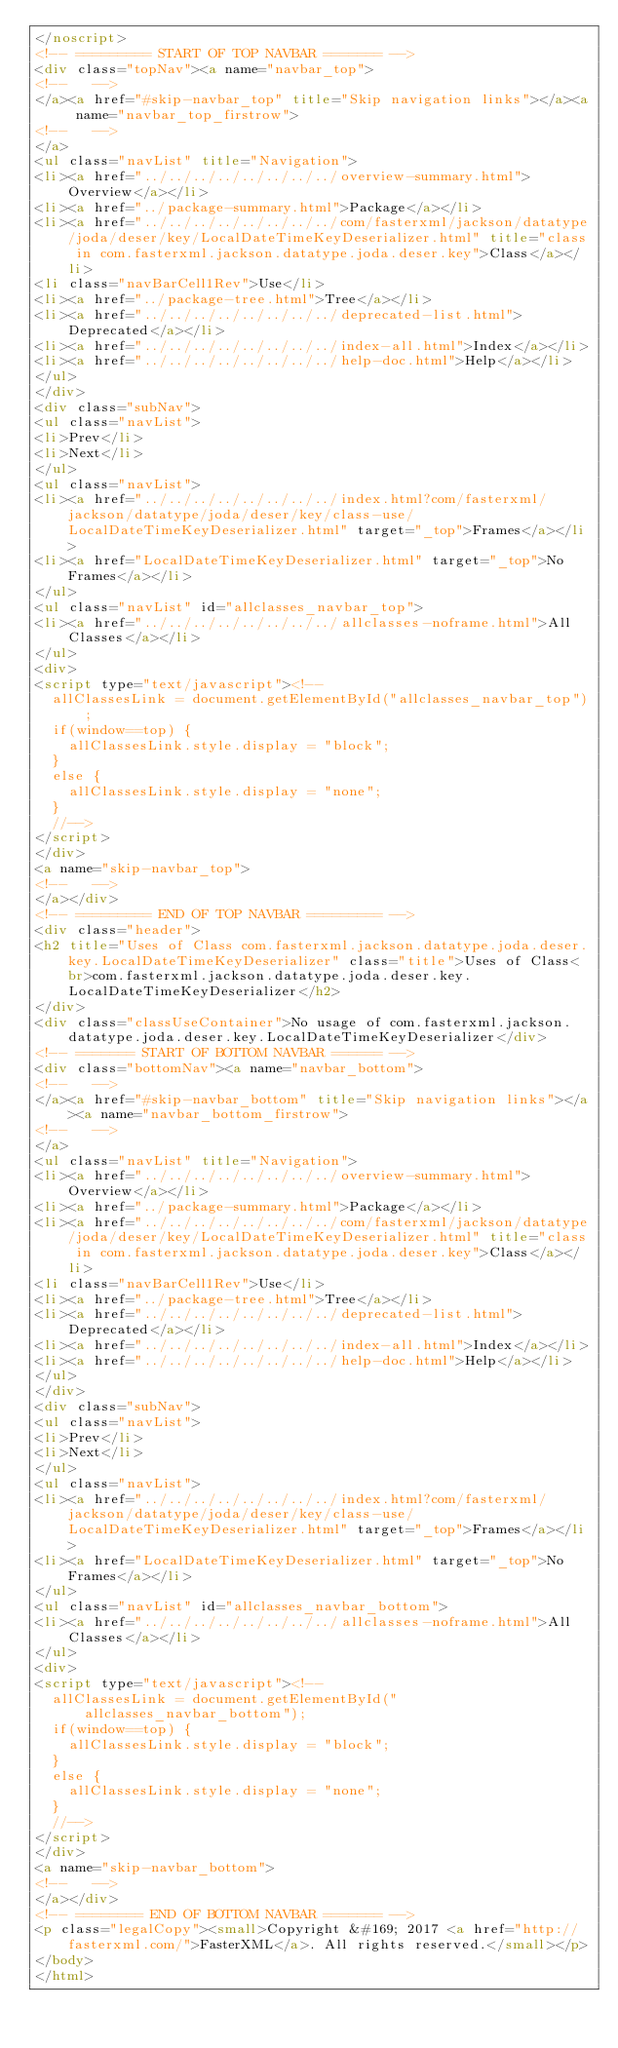Convert code to text. <code><loc_0><loc_0><loc_500><loc_500><_HTML_></noscript>
<!-- ========= START OF TOP NAVBAR ======= -->
<div class="topNav"><a name="navbar_top">
<!--   -->
</a><a href="#skip-navbar_top" title="Skip navigation links"></a><a name="navbar_top_firstrow">
<!--   -->
</a>
<ul class="navList" title="Navigation">
<li><a href="../../../../../../../../overview-summary.html">Overview</a></li>
<li><a href="../package-summary.html">Package</a></li>
<li><a href="../../../../../../../../com/fasterxml/jackson/datatype/joda/deser/key/LocalDateTimeKeyDeserializer.html" title="class in com.fasterxml.jackson.datatype.joda.deser.key">Class</a></li>
<li class="navBarCell1Rev">Use</li>
<li><a href="../package-tree.html">Tree</a></li>
<li><a href="../../../../../../../../deprecated-list.html">Deprecated</a></li>
<li><a href="../../../../../../../../index-all.html">Index</a></li>
<li><a href="../../../../../../../../help-doc.html">Help</a></li>
</ul>
</div>
<div class="subNav">
<ul class="navList">
<li>Prev</li>
<li>Next</li>
</ul>
<ul class="navList">
<li><a href="../../../../../../../../index.html?com/fasterxml/jackson/datatype/joda/deser/key/class-use/LocalDateTimeKeyDeserializer.html" target="_top">Frames</a></li>
<li><a href="LocalDateTimeKeyDeserializer.html" target="_top">No Frames</a></li>
</ul>
<ul class="navList" id="allclasses_navbar_top">
<li><a href="../../../../../../../../allclasses-noframe.html">All Classes</a></li>
</ul>
<div>
<script type="text/javascript"><!--
  allClassesLink = document.getElementById("allclasses_navbar_top");
  if(window==top) {
    allClassesLink.style.display = "block";
  }
  else {
    allClassesLink.style.display = "none";
  }
  //-->
</script>
</div>
<a name="skip-navbar_top">
<!--   -->
</a></div>
<!-- ========= END OF TOP NAVBAR ========= -->
<div class="header">
<h2 title="Uses of Class com.fasterxml.jackson.datatype.joda.deser.key.LocalDateTimeKeyDeserializer" class="title">Uses of Class<br>com.fasterxml.jackson.datatype.joda.deser.key.LocalDateTimeKeyDeserializer</h2>
</div>
<div class="classUseContainer">No usage of com.fasterxml.jackson.datatype.joda.deser.key.LocalDateTimeKeyDeserializer</div>
<!-- ======= START OF BOTTOM NAVBAR ====== -->
<div class="bottomNav"><a name="navbar_bottom">
<!--   -->
</a><a href="#skip-navbar_bottom" title="Skip navigation links"></a><a name="navbar_bottom_firstrow">
<!--   -->
</a>
<ul class="navList" title="Navigation">
<li><a href="../../../../../../../../overview-summary.html">Overview</a></li>
<li><a href="../package-summary.html">Package</a></li>
<li><a href="../../../../../../../../com/fasterxml/jackson/datatype/joda/deser/key/LocalDateTimeKeyDeserializer.html" title="class in com.fasterxml.jackson.datatype.joda.deser.key">Class</a></li>
<li class="navBarCell1Rev">Use</li>
<li><a href="../package-tree.html">Tree</a></li>
<li><a href="../../../../../../../../deprecated-list.html">Deprecated</a></li>
<li><a href="../../../../../../../../index-all.html">Index</a></li>
<li><a href="../../../../../../../../help-doc.html">Help</a></li>
</ul>
</div>
<div class="subNav">
<ul class="navList">
<li>Prev</li>
<li>Next</li>
</ul>
<ul class="navList">
<li><a href="../../../../../../../../index.html?com/fasterxml/jackson/datatype/joda/deser/key/class-use/LocalDateTimeKeyDeserializer.html" target="_top">Frames</a></li>
<li><a href="LocalDateTimeKeyDeserializer.html" target="_top">No Frames</a></li>
</ul>
<ul class="navList" id="allclasses_navbar_bottom">
<li><a href="../../../../../../../../allclasses-noframe.html">All Classes</a></li>
</ul>
<div>
<script type="text/javascript"><!--
  allClassesLink = document.getElementById("allclasses_navbar_bottom");
  if(window==top) {
    allClassesLink.style.display = "block";
  }
  else {
    allClassesLink.style.display = "none";
  }
  //-->
</script>
</div>
<a name="skip-navbar_bottom">
<!--   -->
</a></div>
<!-- ======== END OF BOTTOM NAVBAR ======= -->
<p class="legalCopy"><small>Copyright &#169; 2017 <a href="http://fasterxml.com/">FasterXML</a>. All rights reserved.</small></p>
</body>
</html>
</code> 